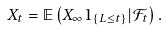<formula> <loc_0><loc_0><loc_500><loc_500>X _ { t } = \mathbb { E } \left ( X _ { \infty } 1 _ { \left \{ L \leq t \right \} } | \mathcal { F } _ { t } \right ) .</formula> 